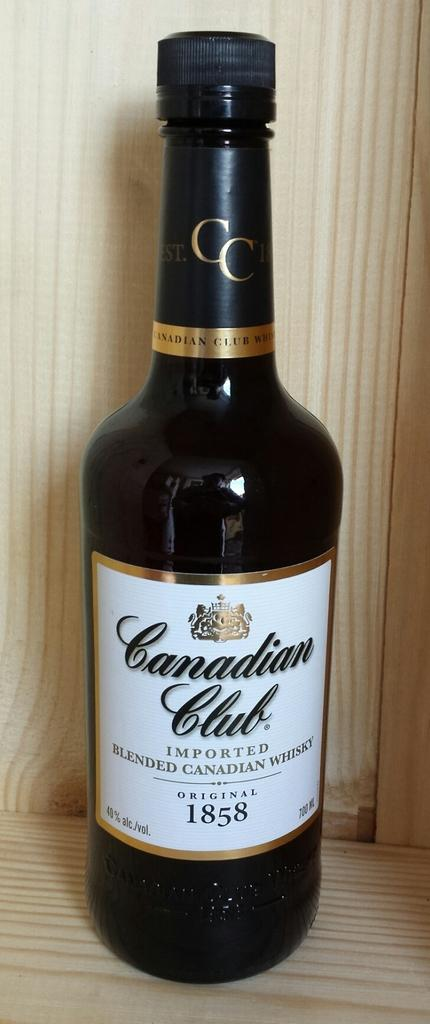<image>
Describe the image concisely. A brown bottle of beer called canadian club. 